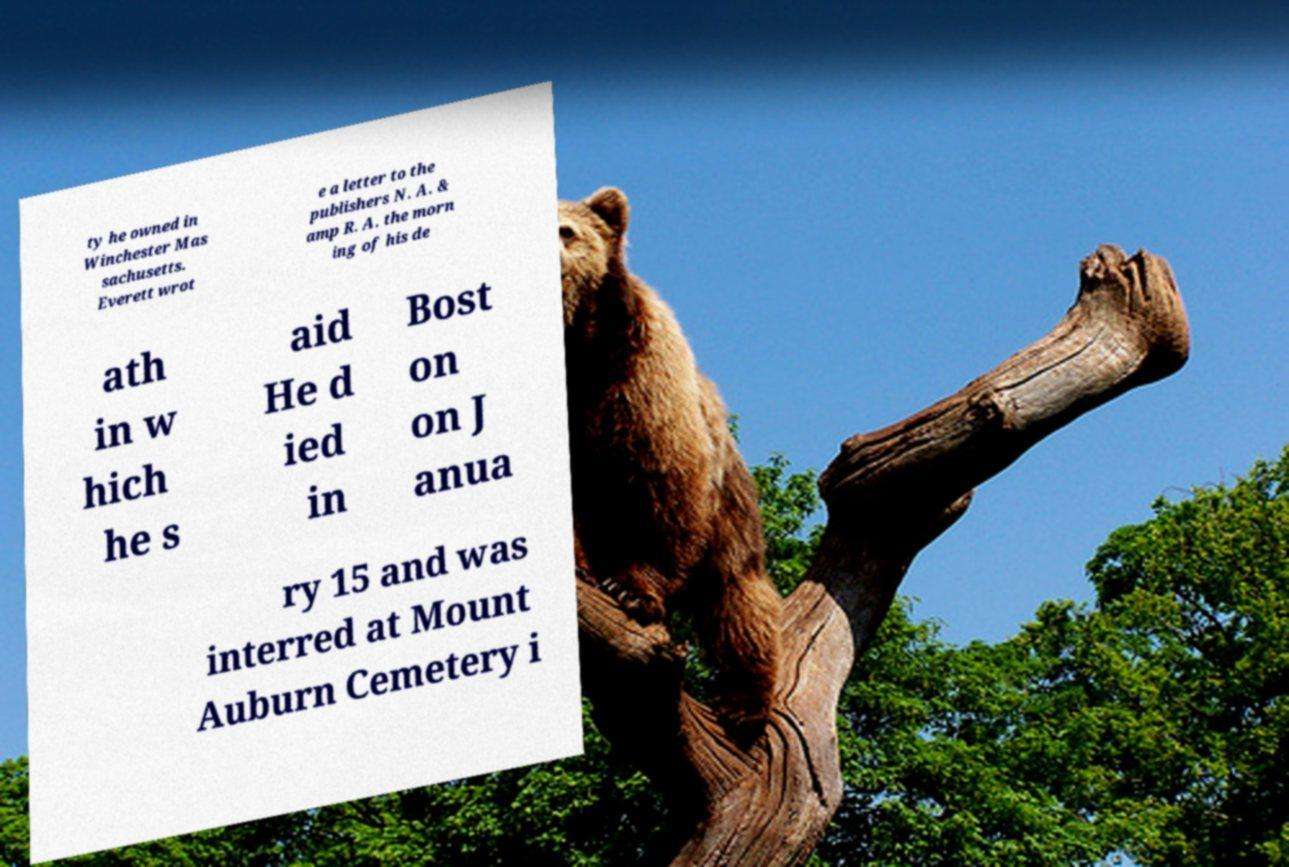Can you accurately transcribe the text from the provided image for me? ty he owned in Winchester Mas sachusetts. Everett wrot e a letter to the publishers N. A. & amp R. A. the morn ing of his de ath in w hich he s aid He d ied in Bost on on J anua ry 15 and was interred at Mount Auburn Cemetery i 